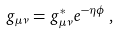<formula> <loc_0><loc_0><loc_500><loc_500>g _ { \mu \nu } = g _ { \mu \nu } ^ { * } e ^ { - \eta \phi } \, ,</formula> 